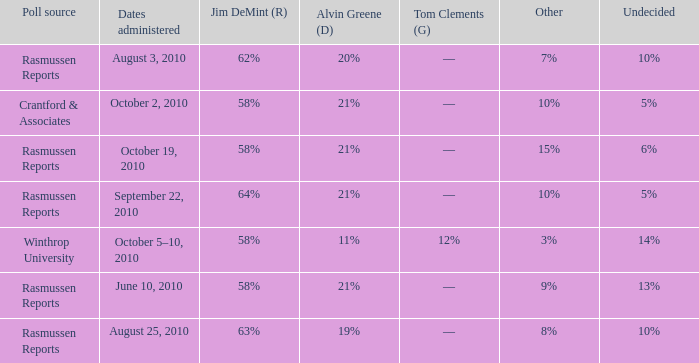What was the vote for Alvin Green when Jim DeMint was 62%? 20%. 